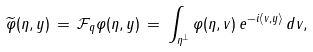Convert formula to latex. <formula><loc_0><loc_0><loc_500><loc_500>\widetilde { \varphi } ( \eta , y ) \, = \, \mathcal { F } _ { q } \varphi ( \eta , y ) \, = \, \int _ { \eta ^ { \perp } } \varphi ( \eta , v ) \, e ^ { - i \langle v , y \rangle } \, d v ,</formula> 